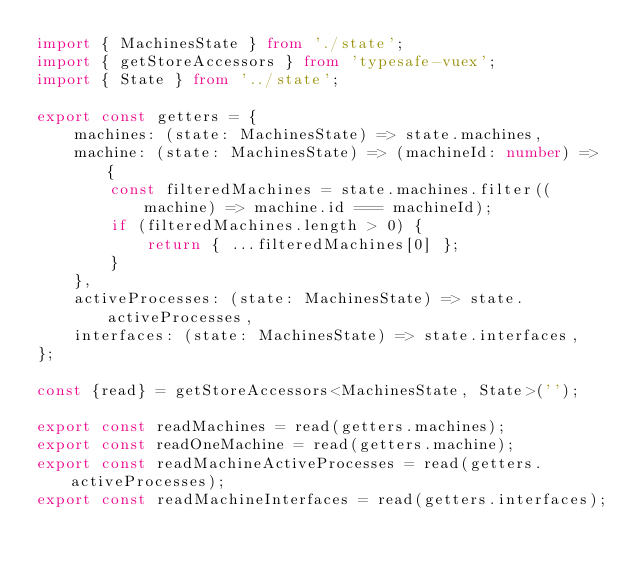<code> <loc_0><loc_0><loc_500><loc_500><_TypeScript_>import { MachinesState } from './state';
import { getStoreAccessors } from 'typesafe-vuex';
import { State } from '../state';

export const getters = {
    machines: (state: MachinesState) => state.machines,
    machine: (state: MachinesState) => (machineId: number) => {
        const filteredMachines = state.machines.filter((machine) => machine.id === machineId);
        if (filteredMachines.length > 0) {
            return { ...filteredMachines[0] };
        }
    },
    activeProcesses: (state: MachinesState) => state.activeProcesses,
    interfaces: (state: MachinesState) => state.interfaces,
};

const {read} = getStoreAccessors<MachinesState, State>('');

export const readMachines = read(getters.machines);
export const readOneMachine = read(getters.machine);
export const readMachineActiveProcesses = read(getters.activeProcesses);
export const readMachineInterfaces = read(getters.interfaces);
</code> 